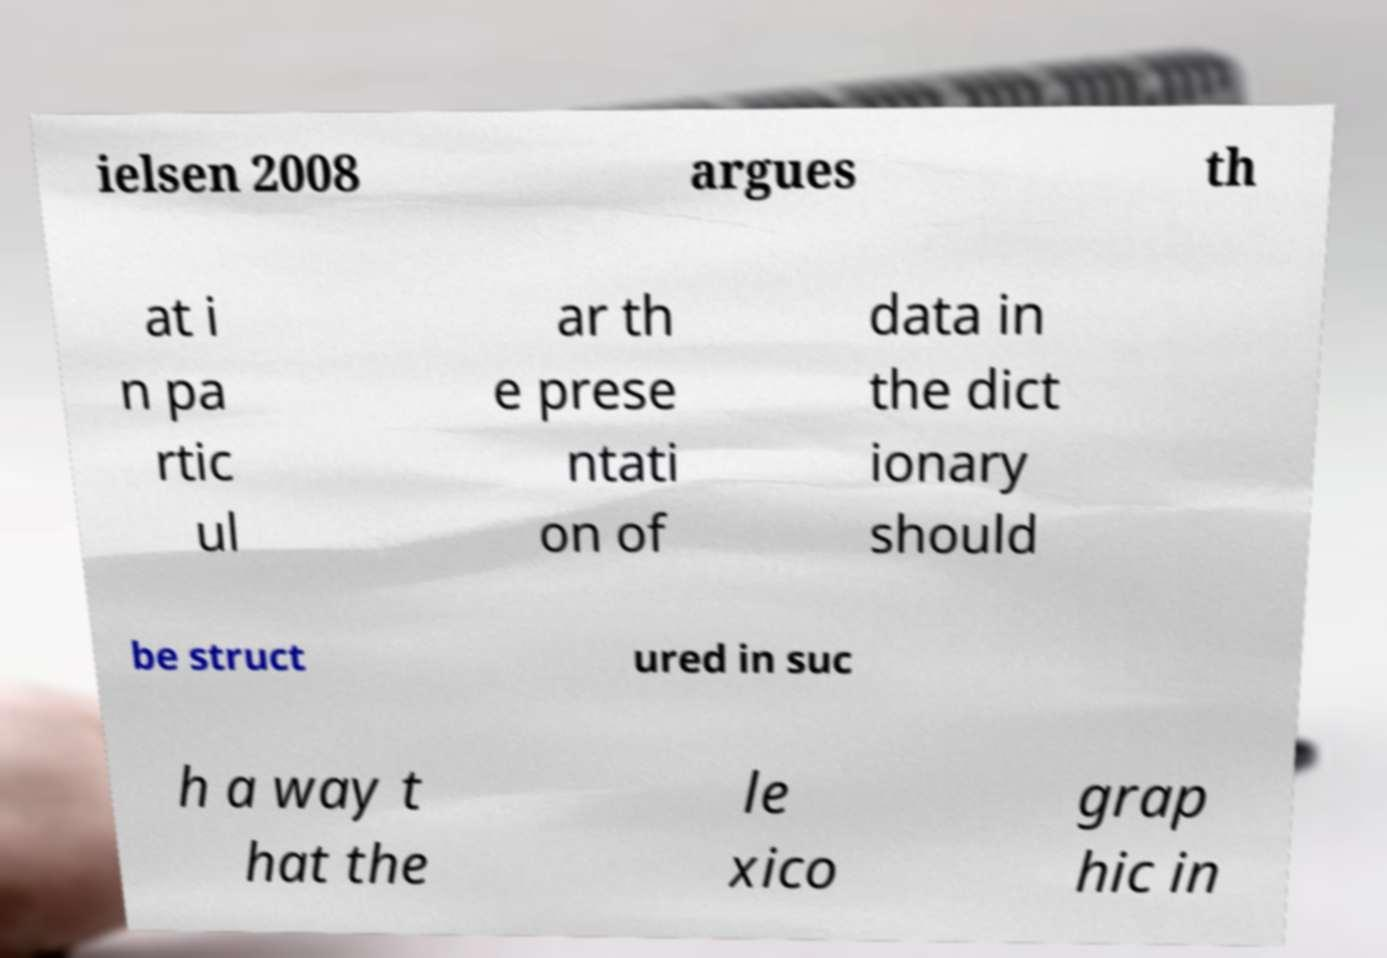I need the written content from this picture converted into text. Can you do that? ielsen 2008 argues th at i n pa rtic ul ar th e prese ntati on of data in the dict ionary should be struct ured in suc h a way t hat the le xico grap hic in 